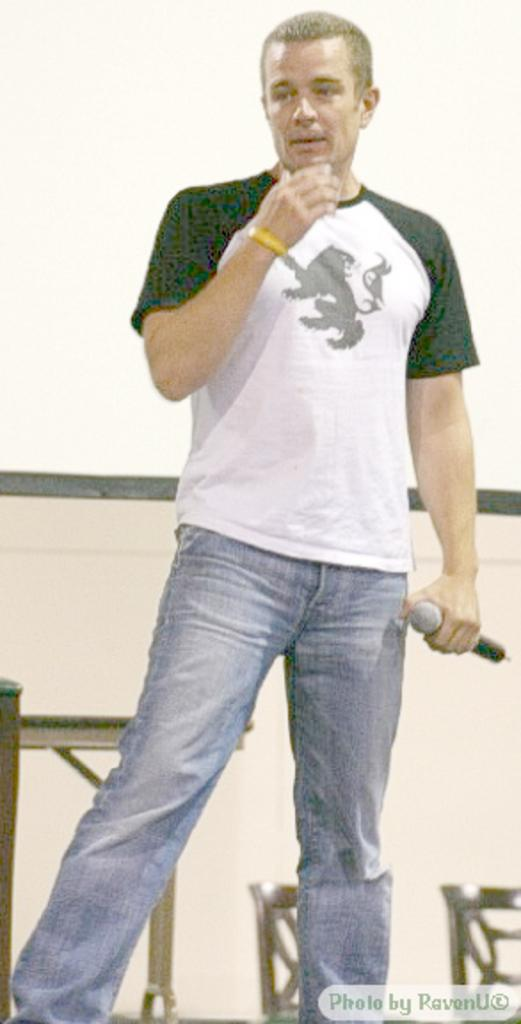What is the person in the image doing? The person is standing in the image. What object is the person holding? The person is holding a microphone. What can be seen in the background of the image? There are chairs visible in the background of the image. Is the person in the image sinking into quicksand? No, there is no quicksand present in the image. What type of coat is the person wearing in the image? The person is not wearing a coat in the image. 